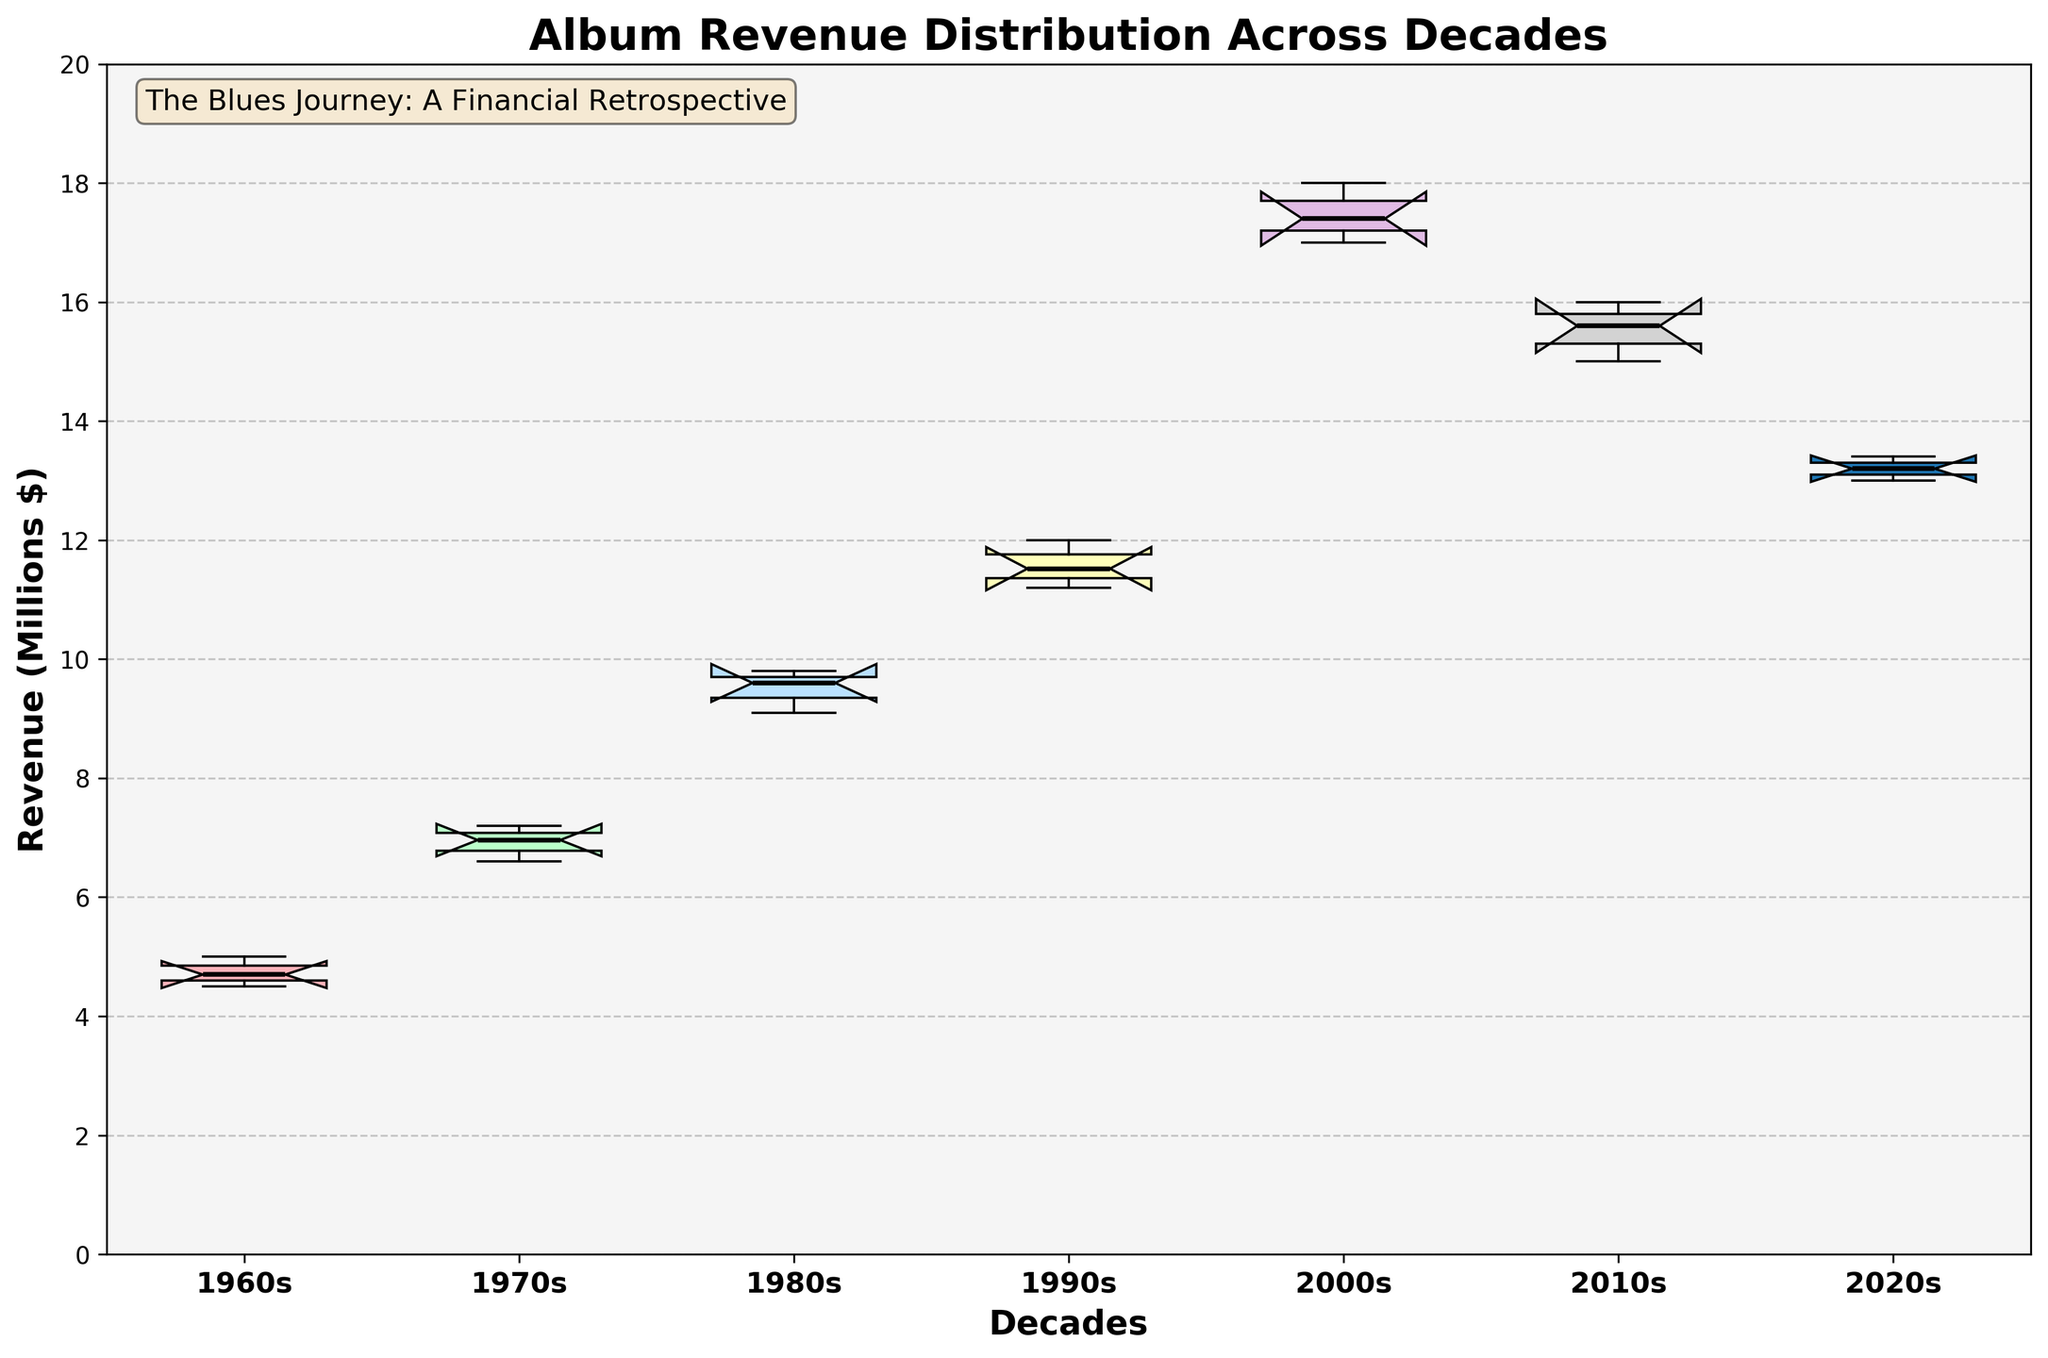What is the title of the figure? The title is typically displayed at the top of the figure. It provides an overview of what the plot represents.
Answer: Album Revenue Distribution Across Decades What is the range of the y-axis on the figure? The range of the y-axis can be seen along the vertical axis of the plot. This information is typically indicated by the lowest and highest values marked on the axis. In this case, the y-axis ranges from 0 to 20.
Answer: 0 to 20 How many decades are represented in the box plot? By counting the labels on the x-axis, which correspond to different decades, we can determine the number of decades represented in the plot.
Answer: 6 Which decade has the highest median revenue? To find the decade with the highest median revenue, look at the position of the black line (representing the median) within each box. The decade with the median line at the highest value on the y-axis has the highest median revenue.
Answer: 2000s How does the variance in revenue change from the 1960s to the 2000s? To analyze the variance in revenue, observe the width of the boxes and the spread of the whiskers in the box plot for the 1960s and compare it with the 2000s. The height and spread of these elements indicate the variability in revenue within each decade.
Answer: The variance increases from the 1960s to the 2000s Which decade shows the smallest interquartile range (IQR) in revenue? The IQR is the range between the first quartile (bottom of the box) and the third quartile (top of the box). By comparing the heights of the boxes, we can identify which one is the smallest.
Answer: 1960s What is the approximate median revenue in the 2010s? The median revenue is represented by the line inside the box for the 2010s. By locating this line within the 2010s box and checking its position on the y-axis, we can estimate the median revenue.
Answer: ~15 million dollars How do the revenues in the 1980s compare to the 2020s? To compare the revenues, look at the medians and the spread (range) of the box plots for both decades.
Answer: Revenues in the 1980s are generally lower and more varied than in the 2020s In which decade do we see the most outliers? Outliers are represented by points outside the whiskers of the box plots. By counting these points for each decade, we can determine which one has the most.
Answer: 1980s Which decade has the highest upper quartile value? The upper quartile value is represented by the top edge of the box. By finding the highest top edge on the y-axis, we identify the decade with the highest upper quartile value.
Answer: 2000s 